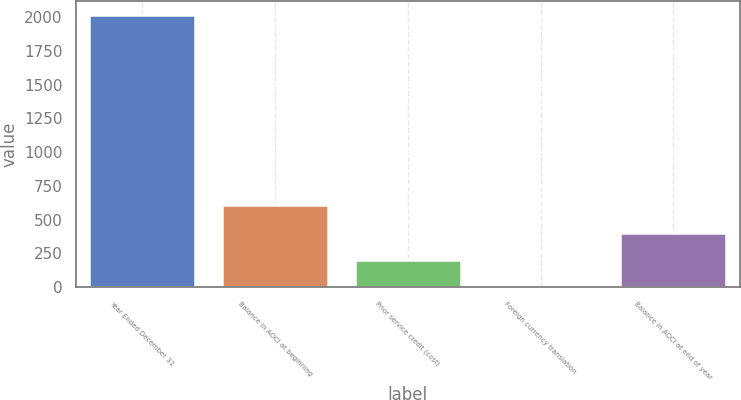<chart> <loc_0><loc_0><loc_500><loc_500><bar_chart><fcel>Year Ended December 31<fcel>Balance in AOCI at beginning<fcel>Prior service credit (cost)<fcel>Foreign currency translation<fcel>Balance in AOCI at end of year<nl><fcel>2017<fcel>605.8<fcel>202.6<fcel>1<fcel>404.2<nl></chart> 